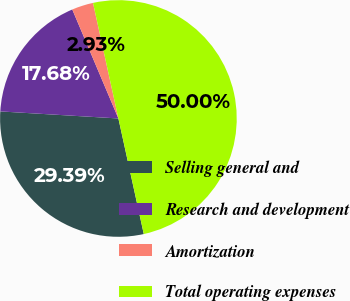<chart> <loc_0><loc_0><loc_500><loc_500><pie_chart><fcel>Selling general and<fcel>Research and development<fcel>Amortization<fcel>Total operating expenses<nl><fcel>29.39%<fcel>17.68%<fcel>2.93%<fcel>50.0%<nl></chart> 